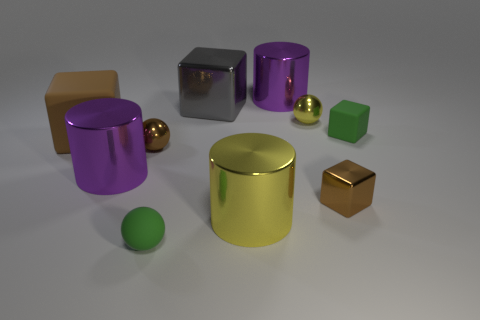How many other objects are there of the same material as the big yellow cylinder?
Provide a short and direct response. 6. What is the color of the small rubber object that is behind the big brown rubber object?
Keep it short and to the point. Green. There is a big purple object to the left of the metallic sphere to the left of the purple metallic object behind the tiny green cube; what is it made of?
Your answer should be very brief. Metal. Is there a small brown object that has the same shape as the big brown object?
Your answer should be compact. Yes. What shape is the brown object that is the same size as the brown metallic ball?
Give a very brief answer. Cube. How many small cubes are in front of the brown rubber cube and behind the brown matte block?
Provide a short and direct response. 0. Are there fewer tiny metallic blocks that are behind the brown matte thing than tiny brown objects?
Make the answer very short. Yes. Are there any other brown metal balls that have the same size as the brown shiny sphere?
Provide a succinct answer. No. What color is the other small sphere that is the same material as the brown ball?
Your answer should be very brief. Yellow. What number of small green balls are on the right side of the small green object behind the brown matte object?
Provide a succinct answer. 0. 